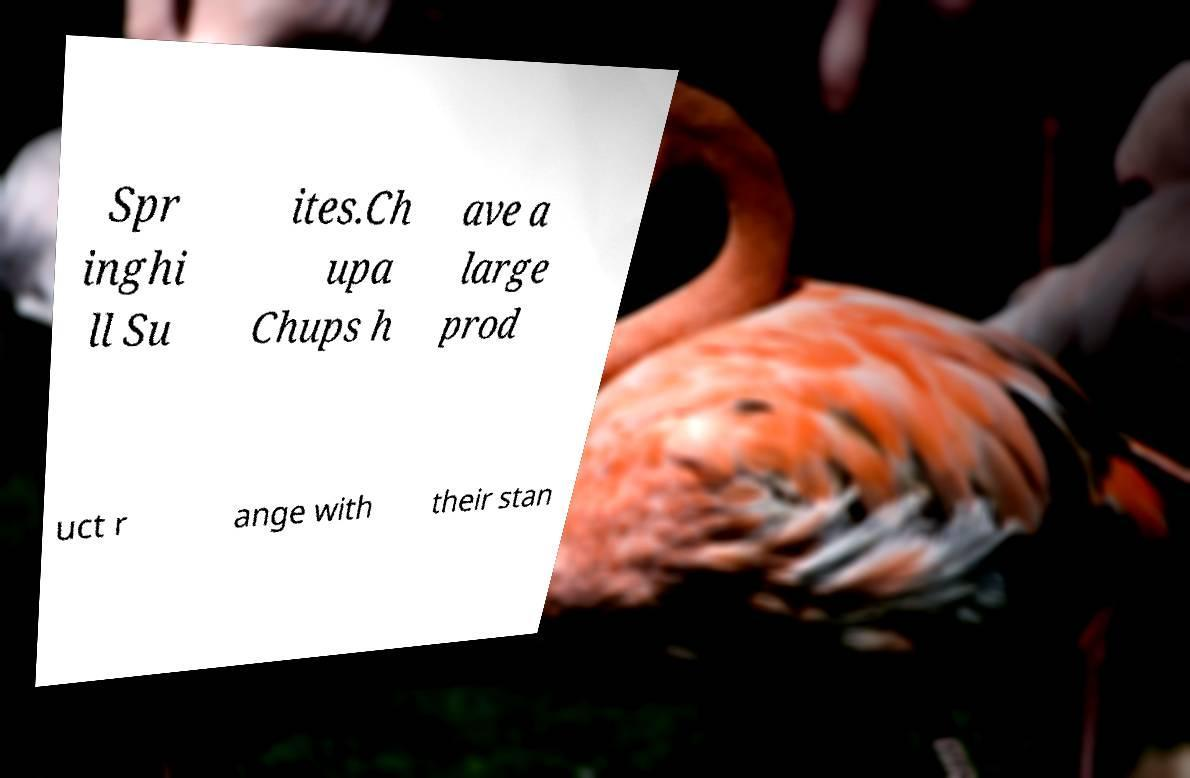Can you read and provide the text displayed in the image?This photo seems to have some interesting text. Can you extract and type it out for me? Spr inghi ll Su ites.Ch upa Chups h ave a large prod uct r ange with their stan 